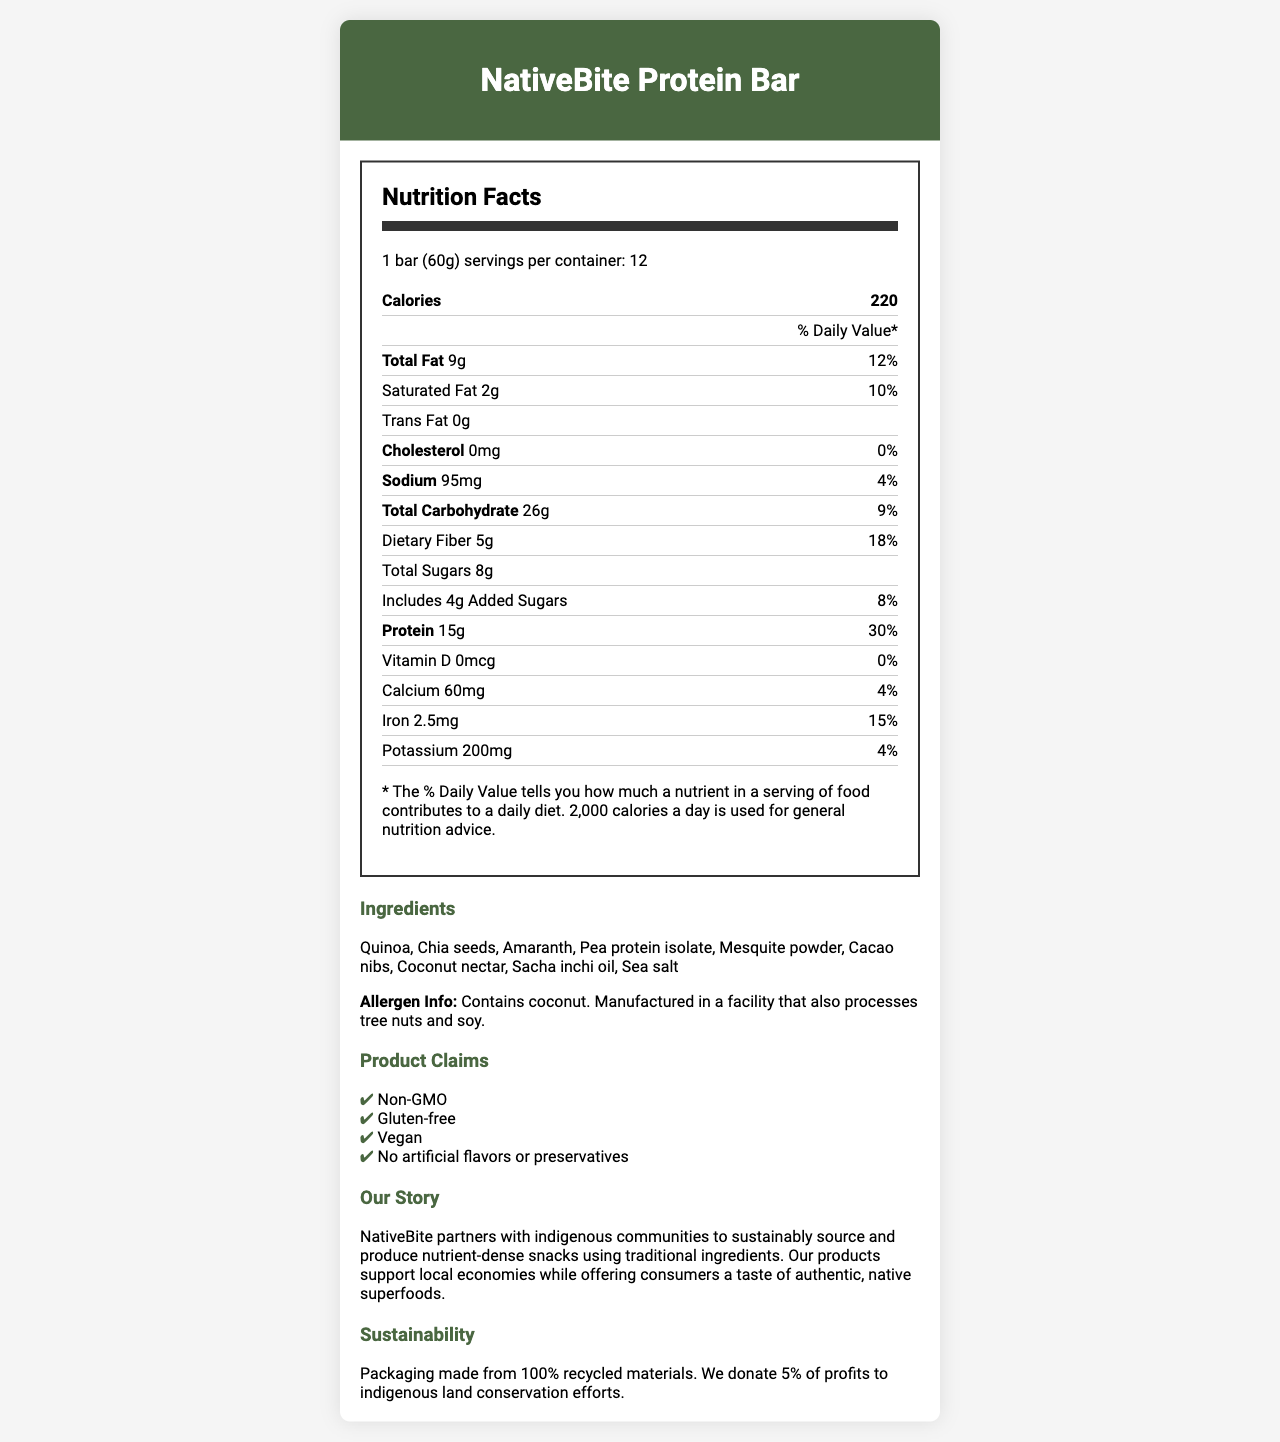what is the product name? The product name is stated at the top of the document within the header section.
Answer: NativeBite Protein Bar what is the serving size? The serving size information is listed at the beginning of the Nutrition Facts section.
Answer: 1 bar (60g) how many servings are in each container? The number of servings per container is indicated within the Nutrition Facts section.
Answer: 12 how many grams of protein are in one serving? The amount of protein per serving is listed in the Nutrition Facts table under the "Protein" row.
Answer: 15g what is the % daily value of dietary fiber per serving? The % daily value of dietary fiber is specified under the "Dietary Fiber" row in the Nutrition Facts table.
Answer: 18% which ingredients are used in this product? The ingredients are listed in the Ingredients section of the document.
Answer: Quinoa, Chia seeds, Amaranth, Pea protein isolate, Mesquite powder, Cacao nibs, Coconut nectar, Sacha inchi oil, Sea salt how many calories are in one serving? The number of calories per serving is noted at the top of the Nutrition Facts table.
Answer: 220 what is the % daily value of iron per serving? The % daily value of iron is given in the Nutrition Facts table under the "Iron" row.
Answer: 15% is the product gluten-free? The claim "Gluten-free" is listed under the Product Claims section.
Answer: Yes is the product manufactured in a facility that processes tree nuts and soy? This information is mentioned in the Allergen Info note under the Ingredients section.
Answer: Yes what % of profits is donated to indigenous land conservation efforts? A. 2% B. 5% C. 10% D. 20% The sustainability statement mentions that 5% of profits are donated to indigenous land conservation efforts.
Answer: B. 5% how much calcium is in one serving? A. 30mg B. 50mg C. 60mg D. 100mg The amount of calcium per serving is listed in the Nutrition Facts table under the "Calcium" row.
Answer: C. 60mg does the product contain any added sugars? The product contains 4g of added sugars per serving, as indicated in the Nutrition Facts table.
Answer: Yes what is the main purpose of NativeBite's partnership with indigenous communities? The brand story mentions that NativeBite partners with indigenous communities to sustainably source and produce nutrient-dense snacks while supporting local economies.
Answer: Support local economies and produce nutrient-dense snacks using traditional ingredients how many milligrams of sodium are in each serving? The amount of sodium per serving is listed in the Nutrition Facts table under the "Sodium" row.
Answer: 95mg can the exact calorie burn from consuming this product without exercise be determined from the document? The document provides nutrition facts but does not offer information on individual calorie expenditure or burn rates.
Answer: Not enough information describe the main idea of the document. The document includes sections on nutrition facts, ingredients, product claims, the brand story, and sustainability, all highlighting the product's health benefits and ethical practices.
Answer: The document provides detailed nutrition facts and ingredient information for the NativeBite Protein Bar, emphasizing its health benefits, sustainability efforts, and support for indigenous communities. 